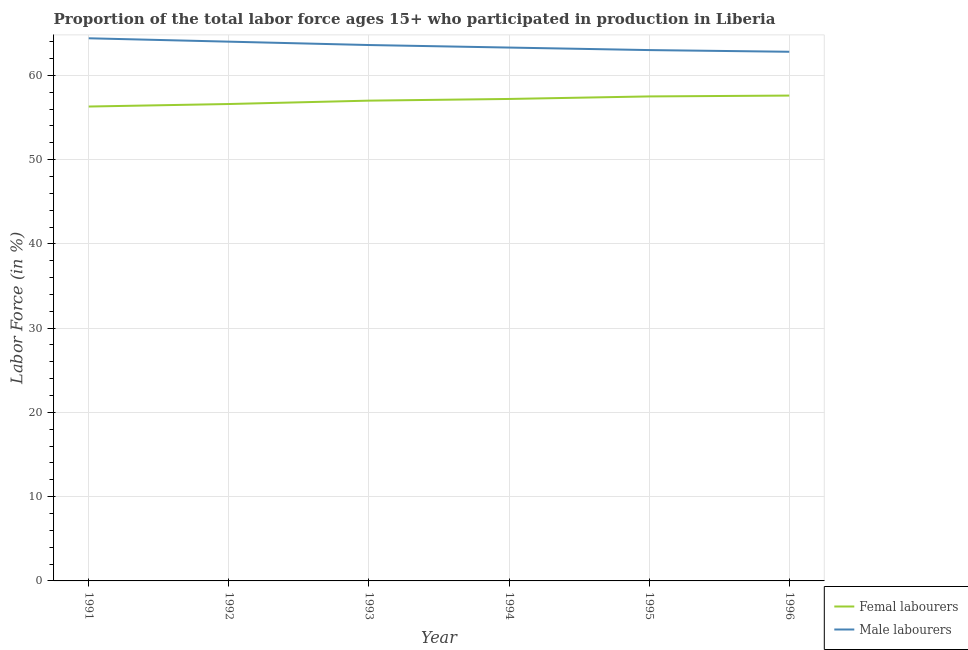How many different coloured lines are there?
Ensure brevity in your answer.  2. Is the number of lines equal to the number of legend labels?
Your answer should be compact. Yes. What is the percentage of male labour force in 1996?
Provide a short and direct response. 62.8. Across all years, what is the maximum percentage of female labor force?
Your response must be concise. 57.6. Across all years, what is the minimum percentage of male labour force?
Provide a succinct answer. 62.8. In which year was the percentage of female labor force maximum?
Provide a short and direct response. 1996. In which year was the percentage of female labor force minimum?
Keep it short and to the point. 1991. What is the total percentage of male labour force in the graph?
Your answer should be very brief. 381.1. What is the difference between the percentage of male labour force in 1996 and the percentage of female labor force in 1995?
Keep it short and to the point. 5.3. What is the average percentage of male labour force per year?
Ensure brevity in your answer.  63.52. In the year 1995, what is the difference between the percentage of male labour force and percentage of female labor force?
Provide a short and direct response. 5.5. What is the ratio of the percentage of male labour force in 1992 to that in 1993?
Give a very brief answer. 1.01. Is the percentage of male labour force in 1993 less than that in 1995?
Keep it short and to the point. No. What is the difference between the highest and the second highest percentage of male labour force?
Your response must be concise. 0.4. What is the difference between the highest and the lowest percentage of male labour force?
Your answer should be very brief. 1.6. In how many years, is the percentage of male labour force greater than the average percentage of male labour force taken over all years?
Offer a terse response. 3. Is the percentage of female labor force strictly less than the percentage of male labour force over the years?
Ensure brevity in your answer.  Yes. What is the difference between two consecutive major ticks on the Y-axis?
Keep it short and to the point. 10. Are the values on the major ticks of Y-axis written in scientific E-notation?
Offer a very short reply. No. Does the graph contain any zero values?
Ensure brevity in your answer.  No. Does the graph contain grids?
Your response must be concise. Yes. Where does the legend appear in the graph?
Your answer should be compact. Bottom right. How many legend labels are there?
Offer a very short reply. 2. What is the title of the graph?
Provide a short and direct response. Proportion of the total labor force ages 15+ who participated in production in Liberia. Does "By country of asylum" appear as one of the legend labels in the graph?
Make the answer very short. No. What is the label or title of the Y-axis?
Keep it short and to the point. Labor Force (in %). What is the Labor Force (in %) of Femal labourers in 1991?
Offer a very short reply. 56.3. What is the Labor Force (in %) of Male labourers in 1991?
Offer a terse response. 64.4. What is the Labor Force (in %) in Femal labourers in 1992?
Keep it short and to the point. 56.6. What is the Labor Force (in %) of Male labourers in 1993?
Your response must be concise. 63.6. What is the Labor Force (in %) in Femal labourers in 1994?
Keep it short and to the point. 57.2. What is the Labor Force (in %) of Male labourers in 1994?
Make the answer very short. 63.3. What is the Labor Force (in %) of Femal labourers in 1995?
Your answer should be compact. 57.5. What is the Labor Force (in %) in Male labourers in 1995?
Keep it short and to the point. 63. What is the Labor Force (in %) in Femal labourers in 1996?
Your answer should be very brief. 57.6. What is the Labor Force (in %) of Male labourers in 1996?
Your answer should be compact. 62.8. Across all years, what is the maximum Labor Force (in %) of Femal labourers?
Your answer should be compact. 57.6. Across all years, what is the maximum Labor Force (in %) in Male labourers?
Ensure brevity in your answer.  64.4. Across all years, what is the minimum Labor Force (in %) in Femal labourers?
Your response must be concise. 56.3. Across all years, what is the minimum Labor Force (in %) in Male labourers?
Provide a succinct answer. 62.8. What is the total Labor Force (in %) of Femal labourers in the graph?
Offer a terse response. 342.2. What is the total Labor Force (in %) in Male labourers in the graph?
Provide a succinct answer. 381.1. What is the difference between the Labor Force (in %) in Femal labourers in 1991 and that in 1992?
Your answer should be compact. -0.3. What is the difference between the Labor Force (in %) of Male labourers in 1991 and that in 1992?
Offer a very short reply. 0.4. What is the difference between the Labor Force (in %) in Femal labourers in 1991 and that in 1993?
Offer a terse response. -0.7. What is the difference between the Labor Force (in %) in Femal labourers in 1991 and that in 1994?
Offer a terse response. -0.9. What is the difference between the Labor Force (in %) in Male labourers in 1991 and that in 1994?
Your answer should be very brief. 1.1. What is the difference between the Labor Force (in %) in Femal labourers in 1991 and that in 1995?
Provide a succinct answer. -1.2. What is the difference between the Labor Force (in %) of Male labourers in 1991 and that in 1995?
Offer a very short reply. 1.4. What is the difference between the Labor Force (in %) in Femal labourers in 1992 and that in 1993?
Provide a succinct answer. -0.4. What is the difference between the Labor Force (in %) in Femal labourers in 1992 and that in 1994?
Offer a very short reply. -0.6. What is the difference between the Labor Force (in %) in Male labourers in 1992 and that in 1994?
Make the answer very short. 0.7. What is the difference between the Labor Force (in %) in Femal labourers in 1992 and that in 1995?
Provide a short and direct response. -0.9. What is the difference between the Labor Force (in %) in Male labourers in 1992 and that in 1995?
Keep it short and to the point. 1. What is the difference between the Labor Force (in %) in Male labourers in 1992 and that in 1996?
Offer a terse response. 1.2. What is the difference between the Labor Force (in %) in Femal labourers in 1993 and that in 1994?
Ensure brevity in your answer.  -0.2. What is the difference between the Labor Force (in %) of Male labourers in 1993 and that in 1994?
Give a very brief answer. 0.3. What is the difference between the Labor Force (in %) in Male labourers in 1994 and that in 1995?
Your answer should be very brief. 0.3. What is the difference between the Labor Force (in %) in Femal labourers in 1994 and that in 1996?
Your answer should be very brief. -0.4. What is the difference between the Labor Force (in %) in Femal labourers in 1991 and the Labor Force (in %) in Male labourers in 1993?
Provide a short and direct response. -7.3. What is the difference between the Labor Force (in %) of Femal labourers in 1991 and the Labor Force (in %) of Male labourers in 1995?
Your answer should be very brief. -6.7. What is the difference between the Labor Force (in %) of Femal labourers in 1991 and the Labor Force (in %) of Male labourers in 1996?
Provide a short and direct response. -6.5. What is the difference between the Labor Force (in %) of Femal labourers in 1992 and the Labor Force (in %) of Male labourers in 1993?
Offer a terse response. -7. What is the difference between the Labor Force (in %) of Femal labourers in 1992 and the Labor Force (in %) of Male labourers in 1994?
Keep it short and to the point. -6.7. What is the difference between the Labor Force (in %) in Femal labourers in 1992 and the Labor Force (in %) in Male labourers in 1995?
Provide a short and direct response. -6.4. What is the difference between the Labor Force (in %) of Femal labourers in 1992 and the Labor Force (in %) of Male labourers in 1996?
Your answer should be very brief. -6.2. What is the difference between the Labor Force (in %) of Femal labourers in 1993 and the Labor Force (in %) of Male labourers in 1995?
Your response must be concise. -6. What is the difference between the Labor Force (in %) of Femal labourers in 1993 and the Labor Force (in %) of Male labourers in 1996?
Make the answer very short. -5.8. What is the difference between the Labor Force (in %) in Femal labourers in 1994 and the Labor Force (in %) in Male labourers in 1995?
Ensure brevity in your answer.  -5.8. What is the difference between the Labor Force (in %) in Femal labourers in 1995 and the Labor Force (in %) in Male labourers in 1996?
Offer a very short reply. -5.3. What is the average Labor Force (in %) in Femal labourers per year?
Ensure brevity in your answer.  57.03. What is the average Labor Force (in %) in Male labourers per year?
Offer a terse response. 63.52. In the year 1991, what is the difference between the Labor Force (in %) of Femal labourers and Labor Force (in %) of Male labourers?
Provide a succinct answer. -8.1. In the year 1992, what is the difference between the Labor Force (in %) in Femal labourers and Labor Force (in %) in Male labourers?
Offer a terse response. -7.4. In the year 1996, what is the difference between the Labor Force (in %) in Femal labourers and Labor Force (in %) in Male labourers?
Give a very brief answer. -5.2. What is the ratio of the Labor Force (in %) in Male labourers in 1991 to that in 1993?
Ensure brevity in your answer.  1.01. What is the ratio of the Labor Force (in %) of Femal labourers in 1991 to that in 1994?
Offer a very short reply. 0.98. What is the ratio of the Labor Force (in %) in Male labourers in 1991 to that in 1994?
Your answer should be compact. 1.02. What is the ratio of the Labor Force (in %) of Femal labourers in 1991 to that in 1995?
Ensure brevity in your answer.  0.98. What is the ratio of the Labor Force (in %) of Male labourers in 1991 to that in 1995?
Offer a terse response. 1.02. What is the ratio of the Labor Force (in %) of Femal labourers in 1991 to that in 1996?
Offer a terse response. 0.98. What is the ratio of the Labor Force (in %) of Male labourers in 1991 to that in 1996?
Your answer should be compact. 1.03. What is the ratio of the Labor Force (in %) of Femal labourers in 1992 to that in 1994?
Offer a terse response. 0.99. What is the ratio of the Labor Force (in %) in Male labourers in 1992 to that in 1994?
Ensure brevity in your answer.  1.01. What is the ratio of the Labor Force (in %) of Femal labourers in 1992 to that in 1995?
Keep it short and to the point. 0.98. What is the ratio of the Labor Force (in %) in Male labourers in 1992 to that in 1995?
Your answer should be compact. 1.02. What is the ratio of the Labor Force (in %) in Femal labourers in 1992 to that in 1996?
Your response must be concise. 0.98. What is the ratio of the Labor Force (in %) of Male labourers in 1992 to that in 1996?
Your answer should be very brief. 1.02. What is the ratio of the Labor Force (in %) of Male labourers in 1993 to that in 1994?
Give a very brief answer. 1. What is the ratio of the Labor Force (in %) in Male labourers in 1993 to that in 1995?
Make the answer very short. 1.01. What is the ratio of the Labor Force (in %) in Femal labourers in 1993 to that in 1996?
Your response must be concise. 0.99. What is the ratio of the Labor Force (in %) of Male labourers in 1993 to that in 1996?
Provide a succinct answer. 1.01. What is the ratio of the Labor Force (in %) in Femal labourers in 1994 to that in 1995?
Offer a very short reply. 0.99. What is the ratio of the Labor Force (in %) of Male labourers in 1994 to that in 1995?
Give a very brief answer. 1. What is the ratio of the Labor Force (in %) of Male labourers in 1994 to that in 1996?
Provide a succinct answer. 1.01. What is the ratio of the Labor Force (in %) in Femal labourers in 1995 to that in 1996?
Ensure brevity in your answer.  1. What is the difference between the highest and the lowest Labor Force (in %) in Femal labourers?
Your response must be concise. 1.3. 